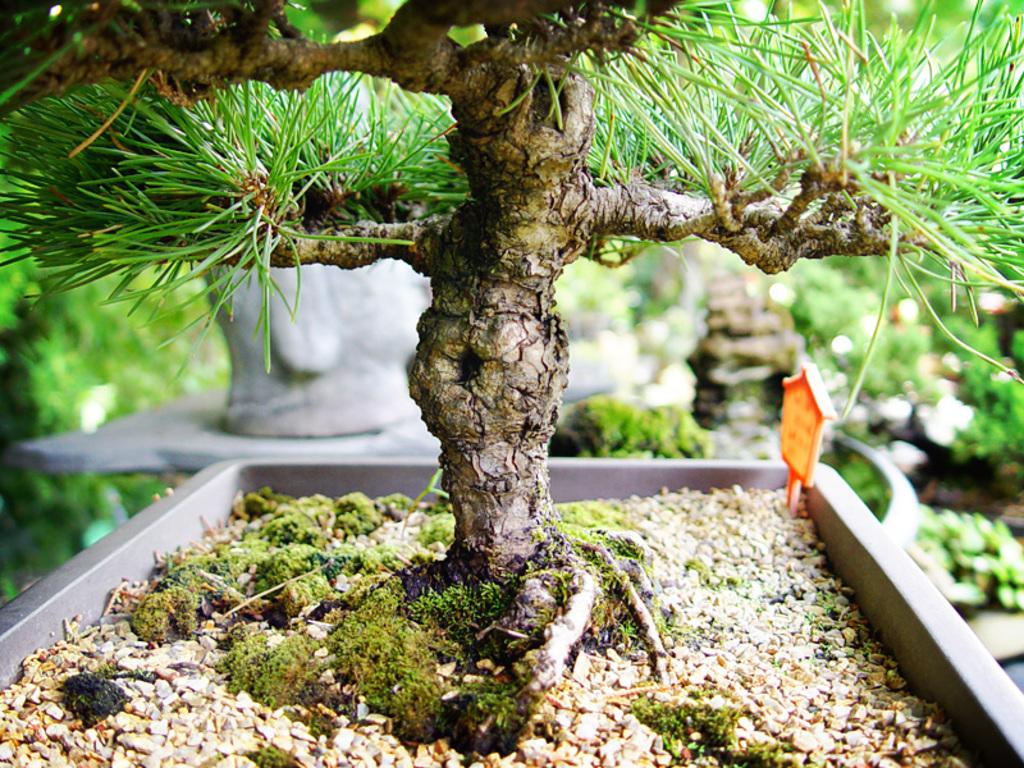What type of living organisms can be seen in the image? Plants and grass can be seen in the image. Can you describe the background of the image? The background of the image is blurred. What type of help is the carpenter providing in the image? There is no carpenter or any indication of help being provided in the image. Can you describe the argument between the two individuals in the image? There are no individuals or any argument present in the image. 